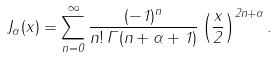Convert formula to latex. <formula><loc_0><loc_0><loc_500><loc_500>J _ { \alpha } ( x ) = \sum _ { n = 0 } ^ { \infty } \frac { ( - 1 ) ^ { n } } { n ! \, \Gamma ( n + \alpha + 1 ) } \left ( \frac { x } { 2 } \right ) ^ { 2 n + \alpha } .</formula> 